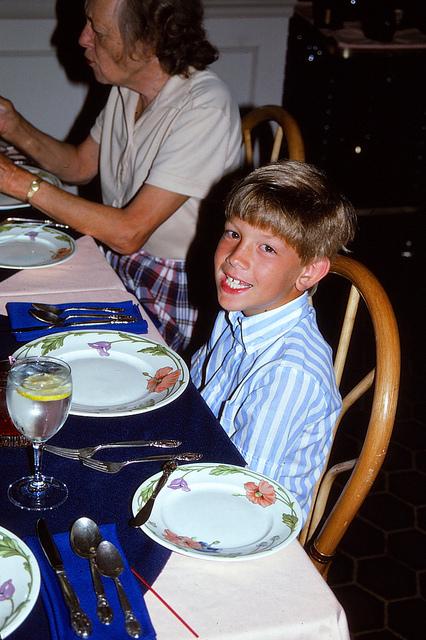Is the boy smiling?
Concise answer only. Yes. Are all the plates empty?
Be succinct. Yes. What is in the water?
Quick response, please. Lemon. 